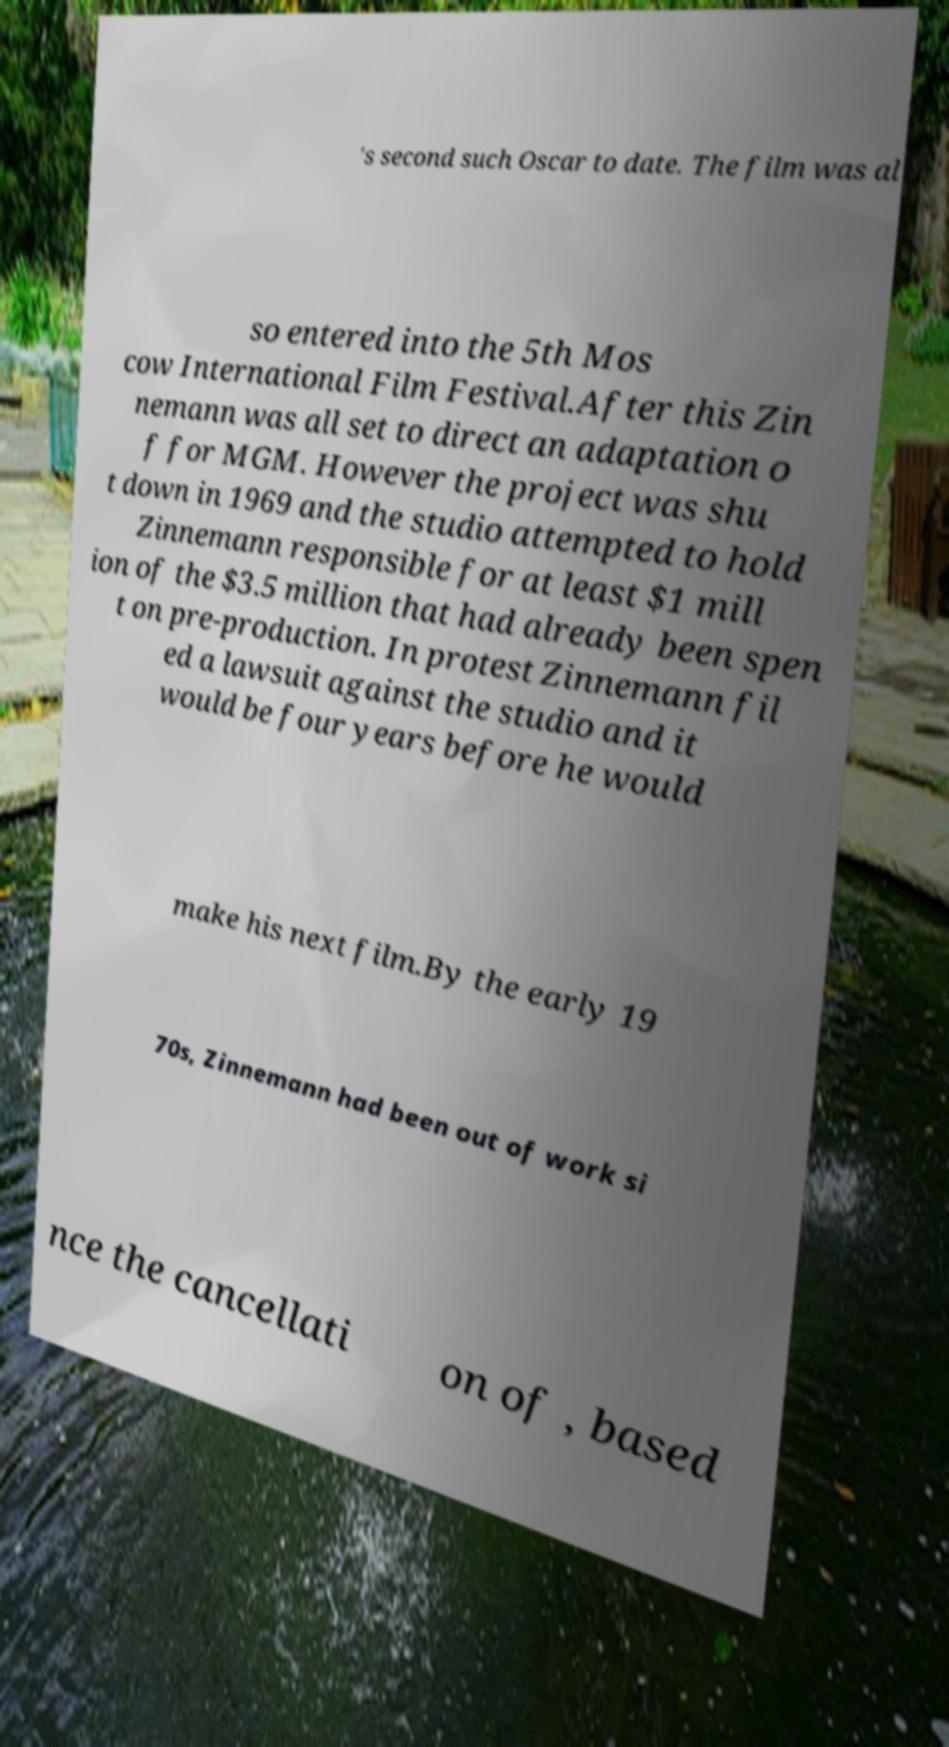Could you extract and type out the text from this image? 's second such Oscar to date. The film was al so entered into the 5th Mos cow International Film Festival.After this Zin nemann was all set to direct an adaptation o f for MGM. However the project was shu t down in 1969 and the studio attempted to hold Zinnemann responsible for at least $1 mill ion of the $3.5 million that had already been spen t on pre-production. In protest Zinnemann fil ed a lawsuit against the studio and it would be four years before he would make his next film.By the early 19 70s, Zinnemann had been out of work si nce the cancellati on of , based 